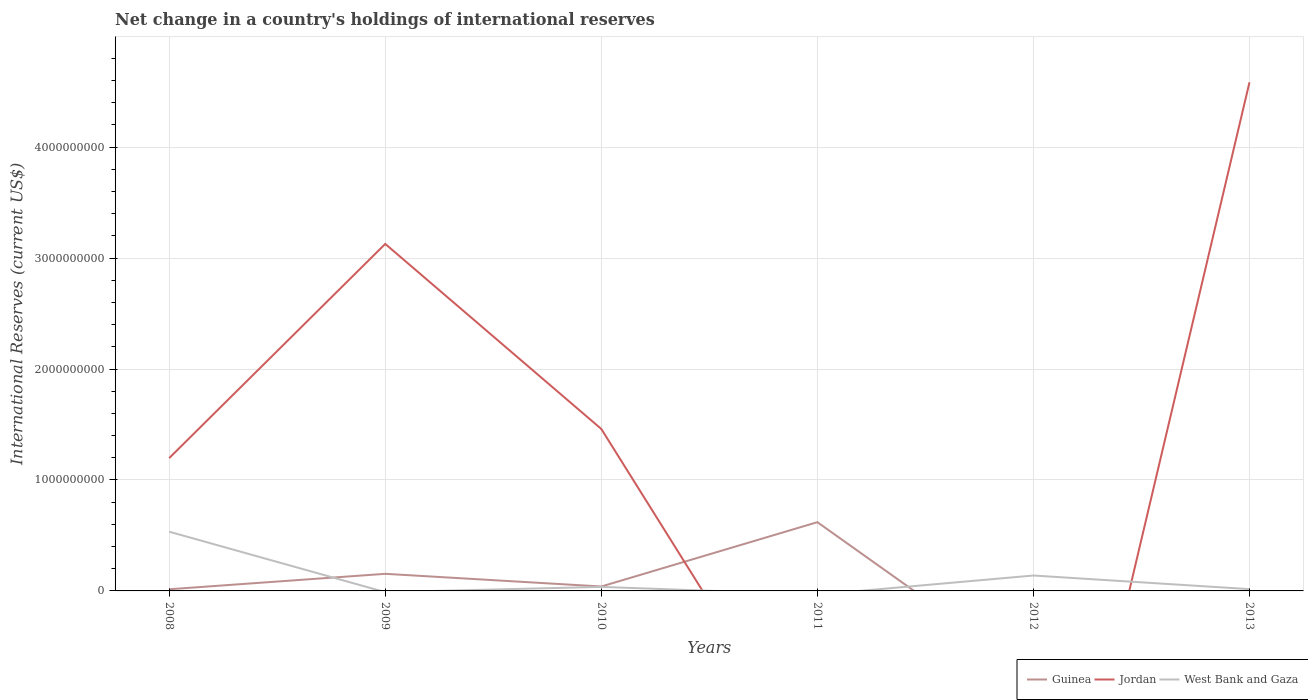How many different coloured lines are there?
Offer a terse response. 3. What is the total international reserves in Guinea in the graph?
Provide a short and direct response. -5.80e+08. What is the difference between the highest and the second highest international reserves in Jordan?
Your response must be concise. 4.58e+09. What is the difference between the highest and the lowest international reserves in Guinea?
Give a very brief answer. 2. Is the international reserves in Guinea strictly greater than the international reserves in Jordan over the years?
Your answer should be compact. No. How many lines are there?
Make the answer very short. 3. What is the difference between two consecutive major ticks on the Y-axis?
Give a very brief answer. 1.00e+09. Are the values on the major ticks of Y-axis written in scientific E-notation?
Your answer should be compact. No. How are the legend labels stacked?
Keep it short and to the point. Horizontal. What is the title of the graph?
Offer a terse response. Net change in a country's holdings of international reserves. What is the label or title of the Y-axis?
Keep it short and to the point. International Reserves (current US$). What is the International Reserves (current US$) of Guinea in 2008?
Your answer should be very brief. 1.50e+07. What is the International Reserves (current US$) of Jordan in 2008?
Your answer should be compact. 1.20e+09. What is the International Reserves (current US$) of West Bank and Gaza in 2008?
Your answer should be very brief. 5.34e+08. What is the International Reserves (current US$) in Guinea in 2009?
Ensure brevity in your answer.  1.54e+08. What is the International Reserves (current US$) in Jordan in 2009?
Keep it short and to the point. 3.13e+09. What is the International Reserves (current US$) of Guinea in 2010?
Your response must be concise. 3.98e+07. What is the International Reserves (current US$) of Jordan in 2010?
Your response must be concise. 1.46e+09. What is the International Reserves (current US$) of West Bank and Gaza in 2010?
Your answer should be compact. 3.64e+07. What is the International Reserves (current US$) of Guinea in 2011?
Give a very brief answer. 6.20e+08. What is the International Reserves (current US$) of Jordan in 2011?
Give a very brief answer. 0. What is the International Reserves (current US$) in Guinea in 2012?
Your answer should be very brief. 0. What is the International Reserves (current US$) in Jordan in 2012?
Your answer should be very brief. 0. What is the International Reserves (current US$) in West Bank and Gaza in 2012?
Your answer should be very brief. 1.39e+08. What is the International Reserves (current US$) in Jordan in 2013?
Offer a very short reply. 4.58e+09. What is the International Reserves (current US$) in West Bank and Gaza in 2013?
Your answer should be compact. 1.60e+07. Across all years, what is the maximum International Reserves (current US$) in Guinea?
Your answer should be very brief. 6.20e+08. Across all years, what is the maximum International Reserves (current US$) in Jordan?
Keep it short and to the point. 4.58e+09. Across all years, what is the maximum International Reserves (current US$) in West Bank and Gaza?
Keep it short and to the point. 5.34e+08. Across all years, what is the minimum International Reserves (current US$) in Guinea?
Provide a succinct answer. 0. Across all years, what is the minimum International Reserves (current US$) of Jordan?
Your response must be concise. 0. What is the total International Reserves (current US$) in Guinea in the graph?
Offer a very short reply. 8.29e+08. What is the total International Reserves (current US$) in Jordan in the graph?
Keep it short and to the point. 1.04e+1. What is the total International Reserves (current US$) in West Bank and Gaza in the graph?
Provide a short and direct response. 7.25e+08. What is the difference between the International Reserves (current US$) in Guinea in 2008 and that in 2009?
Your answer should be very brief. -1.39e+08. What is the difference between the International Reserves (current US$) in Jordan in 2008 and that in 2009?
Provide a succinct answer. -1.93e+09. What is the difference between the International Reserves (current US$) of Guinea in 2008 and that in 2010?
Your response must be concise. -2.48e+07. What is the difference between the International Reserves (current US$) in Jordan in 2008 and that in 2010?
Your response must be concise. -2.63e+08. What is the difference between the International Reserves (current US$) of West Bank and Gaza in 2008 and that in 2010?
Your answer should be very brief. 4.97e+08. What is the difference between the International Reserves (current US$) in Guinea in 2008 and that in 2011?
Provide a succinct answer. -6.05e+08. What is the difference between the International Reserves (current US$) in West Bank and Gaza in 2008 and that in 2012?
Give a very brief answer. 3.95e+08. What is the difference between the International Reserves (current US$) in Jordan in 2008 and that in 2013?
Ensure brevity in your answer.  -3.39e+09. What is the difference between the International Reserves (current US$) in West Bank and Gaza in 2008 and that in 2013?
Provide a succinct answer. 5.18e+08. What is the difference between the International Reserves (current US$) of Guinea in 2009 and that in 2010?
Make the answer very short. 1.14e+08. What is the difference between the International Reserves (current US$) in Jordan in 2009 and that in 2010?
Keep it short and to the point. 1.67e+09. What is the difference between the International Reserves (current US$) in Guinea in 2009 and that in 2011?
Your answer should be compact. -4.65e+08. What is the difference between the International Reserves (current US$) in Jordan in 2009 and that in 2013?
Provide a succinct answer. -1.46e+09. What is the difference between the International Reserves (current US$) of Guinea in 2010 and that in 2011?
Your answer should be very brief. -5.80e+08. What is the difference between the International Reserves (current US$) of West Bank and Gaza in 2010 and that in 2012?
Make the answer very short. -1.02e+08. What is the difference between the International Reserves (current US$) in Jordan in 2010 and that in 2013?
Provide a short and direct response. -3.12e+09. What is the difference between the International Reserves (current US$) of West Bank and Gaza in 2010 and that in 2013?
Provide a succinct answer. 2.04e+07. What is the difference between the International Reserves (current US$) of West Bank and Gaza in 2012 and that in 2013?
Give a very brief answer. 1.23e+08. What is the difference between the International Reserves (current US$) in Guinea in 2008 and the International Reserves (current US$) in Jordan in 2009?
Give a very brief answer. -3.11e+09. What is the difference between the International Reserves (current US$) in Guinea in 2008 and the International Reserves (current US$) in Jordan in 2010?
Offer a very short reply. -1.44e+09. What is the difference between the International Reserves (current US$) in Guinea in 2008 and the International Reserves (current US$) in West Bank and Gaza in 2010?
Keep it short and to the point. -2.14e+07. What is the difference between the International Reserves (current US$) of Jordan in 2008 and the International Reserves (current US$) of West Bank and Gaza in 2010?
Provide a short and direct response. 1.16e+09. What is the difference between the International Reserves (current US$) in Guinea in 2008 and the International Reserves (current US$) in West Bank and Gaza in 2012?
Offer a very short reply. -1.24e+08. What is the difference between the International Reserves (current US$) of Jordan in 2008 and the International Reserves (current US$) of West Bank and Gaza in 2012?
Your response must be concise. 1.06e+09. What is the difference between the International Reserves (current US$) in Guinea in 2008 and the International Reserves (current US$) in Jordan in 2013?
Provide a short and direct response. -4.57e+09. What is the difference between the International Reserves (current US$) of Guinea in 2008 and the International Reserves (current US$) of West Bank and Gaza in 2013?
Your answer should be compact. -9.93e+05. What is the difference between the International Reserves (current US$) of Jordan in 2008 and the International Reserves (current US$) of West Bank and Gaza in 2013?
Provide a short and direct response. 1.18e+09. What is the difference between the International Reserves (current US$) in Guinea in 2009 and the International Reserves (current US$) in Jordan in 2010?
Offer a terse response. -1.31e+09. What is the difference between the International Reserves (current US$) of Guinea in 2009 and the International Reserves (current US$) of West Bank and Gaza in 2010?
Offer a terse response. 1.18e+08. What is the difference between the International Reserves (current US$) in Jordan in 2009 and the International Reserves (current US$) in West Bank and Gaza in 2010?
Provide a short and direct response. 3.09e+09. What is the difference between the International Reserves (current US$) of Guinea in 2009 and the International Reserves (current US$) of West Bank and Gaza in 2012?
Offer a very short reply. 1.52e+07. What is the difference between the International Reserves (current US$) of Jordan in 2009 and the International Reserves (current US$) of West Bank and Gaza in 2012?
Provide a succinct answer. 2.99e+09. What is the difference between the International Reserves (current US$) in Guinea in 2009 and the International Reserves (current US$) in Jordan in 2013?
Your answer should be compact. -4.43e+09. What is the difference between the International Reserves (current US$) of Guinea in 2009 and the International Reserves (current US$) of West Bank and Gaza in 2013?
Give a very brief answer. 1.38e+08. What is the difference between the International Reserves (current US$) of Jordan in 2009 and the International Reserves (current US$) of West Bank and Gaza in 2013?
Your answer should be very brief. 3.11e+09. What is the difference between the International Reserves (current US$) in Guinea in 2010 and the International Reserves (current US$) in West Bank and Gaza in 2012?
Offer a very short reply. -9.91e+07. What is the difference between the International Reserves (current US$) in Jordan in 2010 and the International Reserves (current US$) in West Bank and Gaza in 2012?
Provide a short and direct response. 1.32e+09. What is the difference between the International Reserves (current US$) of Guinea in 2010 and the International Reserves (current US$) of Jordan in 2013?
Your answer should be compact. -4.54e+09. What is the difference between the International Reserves (current US$) in Guinea in 2010 and the International Reserves (current US$) in West Bank and Gaza in 2013?
Provide a succinct answer. 2.38e+07. What is the difference between the International Reserves (current US$) in Jordan in 2010 and the International Reserves (current US$) in West Bank and Gaza in 2013?
Keep it short and to the point. 1.44e+09. What is the difference between the International Reserves (current US$) in Guinea in 2011 and the International Reserves (current US$) in West Bank and Gaza in 2012?
Offer a very short reply. 4.81e+08. What is the difference between the International Reserves (current US$) of Guinea in 2011 and the International Reserves (current US$) of Jordan in 2013?
Provide a short and direct response. -3.96e+09. What is the difference between the International Reserves (current US$) in Guinea in 2011 and the International Reserves (current US$) in West Bank and Gaza in 2013?
Give a very brief answer. 6.04e+08. What is the average International Reserves (current US$) of Guinea per year?
Keep it short and to the point. 1.38e+08. What is the average International Reserves (current US$) of Jordan per year?
Offer a terse response. 1.73e+09. What is the average International Reserves (current US$) in West Bank and Gaza per year?
Offer a very short reply. 1.21e+08. In the year 2008, what is the difference between the International Reserves (current US$) in Guinea and International Reserves (current US$) in Jordan?
Give a very brief answer. -1.18e+09. In the year 2008, what is the difference between the International Reserves (current US$) in Guinea and International Reserves (current US$) in West Bank and Gaza?
Offer a terse response. -5.19e+08. In the year 2008, what is the difference between the International Reserves (current US$) of Jordan and International Reserves (current US$) of West Bank and Gaza?
Give a very brief answer. 6.63e+08. In the year 2009, what is the difference between the International Reserves (current US$) of Guinea and International Reserves (current US$) of Jordan?
Your answer should be very brief. -2.97e+09. In the year 2010, what is the difference between the International Reserves (current US$) in Guinea and International Reserves (current US$) in Jordan?
Offer a terse response. -1.42e+09. In the year 2010, what is the difference between the International Reserves (current US$) in Guinea and International Reserves (current US$) in West Bank and Gaza?
Ensure brevity in your answer.  3.40e+06. In the year 2010, what is the difference between the International Reserves (current US$) of Jordan and International Reserves (current US$) of West Bank and Gaza?
Give a very brief answer. 1.42e+09. In the year 2013, what is the difference between the International Reserves (current US$) in Jordan and International Reserves (current US$) in West Bank and Gaza?
Your answer should be compact. 4.57e+09. What is the ratio of the International Reserves (current US$) in Guinea in 2008 to that in 2009?
Ensure brevity in your answer.  0.1. What is the ratio of the International Reserves (current US$) of Jordan in 2008 to that in 2009?
Your answer should be very brief. 0.38. What is the ratio of the International Reserves (current US$) of Guinea in 2008 to that in 2010?
Make the answer very short. 0.38. What is the ratio of the International Reserves (current US$) of Jordan in 2008 to that in 2010?
Ensure brevity in your answer.  0.82. What is the ratio of the International Reserves (current US$) in West Bank and Gaza in 2008 to that in 2010?
Provide a succinct answer. 14.66. What is the ratio of the International Reserves (current US$) of Guinea in 2008 to that in 2011?
Provide a short and direct response. 0.02. What is the ratio of the International Reserves (current US$) in West Bank and Gaza in 2008 to that in 2012?
Ensure brevity in your answer.  3.84. What is the ratio of the International Reserves (current US$) of Jordan in 2008 to that in 2013?
Ensure brevity in your answer.  0.26. What is the ratio of the International Reserves (current US$) in West Bank and Gaza in 2008 to that in 2013?
Ensure brevity in your answer.  33.38. What is the ratio of the International Reserves (current US$) of Guinea in 2009 to that in 2010?
Give a very brief answer. 3.87. What is the ratio of the International Reserves (current US$) of Jordan in 2009 to that in 2010?
Offer a very short reply. 2.14. What is the ratio of the International Reserves (current US$) in Guinea in 2009 to that in 2011?
Ensure brevity in your answer.  0.25. What is the ratio of the International Reserves (current US$) of Jordan in 2009 to that in 2013?
Your answer should be compact. 0.68. What is the ratio of the International Reserves (current US$) of Guinea in 2010 to that in 2011?
Make the answer very short. 0.06. What is the ratio of the International Reserves (current US$) in West Bank and Gaza in 2010 to that in 2012?
Your response must be concise. 0.26. What is the ratio of the International Reserves (current US$) in Jordan in 2010 to that in 2013?
Your response must be concise. 0.32. What is the ratio of the International Reserves (current US$) in West Bank and Gaza in 2010 to that in 2013?
Your response must be concise. 2.28. What is the ratio of the International Reserves (current US$) of West Bank and Gaza in 2012 to that in 2013?
Provide a short and direct response. 8.68. What is the difference between the highest and the second highest International Reserves (current US$) in Guinea?
Your response must be concise. 4.65e+08. What is the difference between the highest and the second highest International Reserves (current US$) in Jordan?
Keep it short and to the point. 1.46e+09. What is the difference between the highest and the second highest International Reserves (current US$) of West Bank and Gaza?
Your answer should be very brief. 3.95e+08. What is the difference between the highest and the lowest International Reserves (current US$) in Guinea?
Ensure brevity in your answer.  6.20e+08. What is the difference between the highest and the lowest International Reserves (current US$) in Jordan?
Ensure brevity in your answer.  4.58e+09. What is the difference between the highest and the lowest International Reserves (current US$) in West Bank and Gaza?
Offer a terse response. 5.34e+08. 